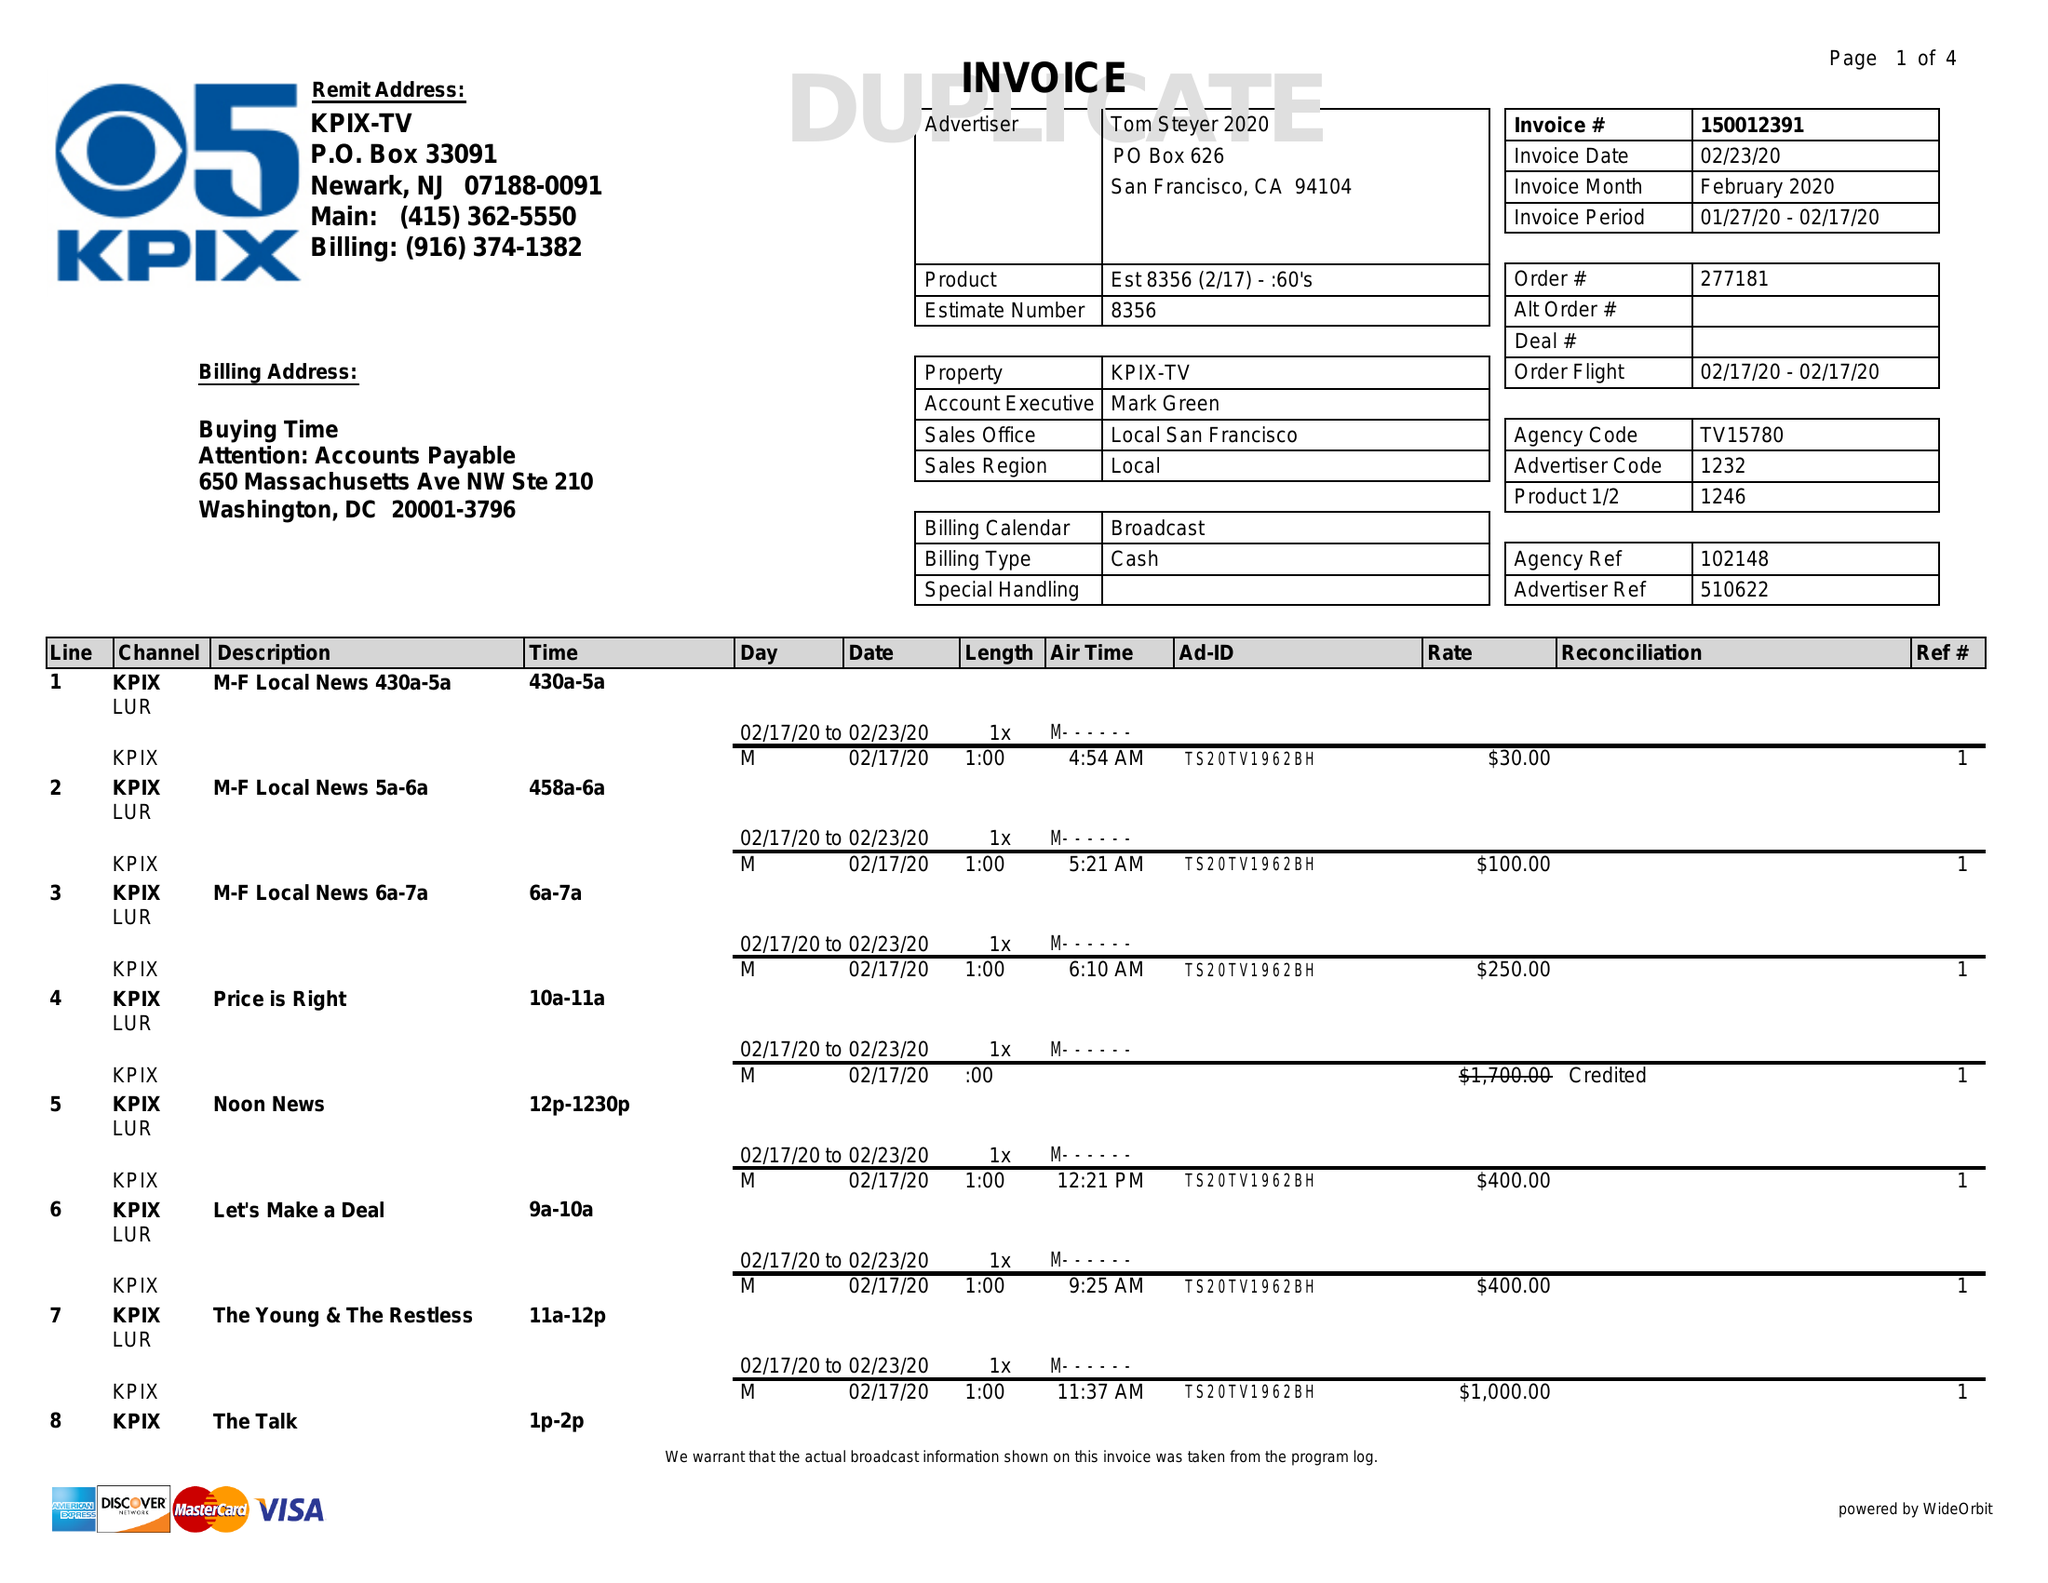What is the value for the contract_num?
Answer the question using a single word or phrase. 150012391 